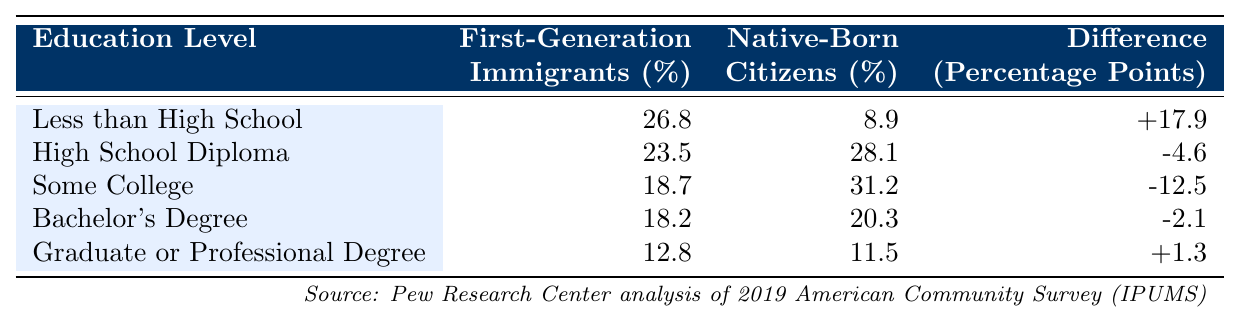What percentage of first-generation immigrants have a Bachelor's degree? From the table, the percentage of first-generation immigrants with a Bachelor's degree is 18.2%.
Answer: 18.2% What is the percentage point difference in the "Less than High School" category between first-generation immigrants and native-born citizens? The table shows that 26.8% of first-generation immigrants fall into this category compared to 8.9% of native-born citizens. The difference is +17.9 percentage points (26.8 - 8.9 = 17.9).
Answer: +17.9 Is it true that a higher percentage of native-born citizens have a Graduate or Professional Degree compared to first-generation immigrants? The table indicates that 12.8% of first-generation immigrants have a Graduate or Professional Degree, while 11.5% of native-born citizens have this degree. Therefore, it is false that a higher percentage of native-born citizens have such a degree.
Answer: No What is the average percentage of first-generation immigrants with some college or lower education levels? Looking at the relevant categories: "Less than High School" (26.8%), "High School Diploma" (23.5%), and "Some College" (18.7%), we add those percentages: 26.8 + 23.5 + 18.7 = 69.0%. There are 3 categories, so the average is 69.0 / 3 = 23.0%.
Answer: 23.0% How many percentage points more likely are first-generation immigrants to have "Less than High School" education than native-born citizens? First-generation immigrants have 26.8% in this category while native-born citizens have 8.9%. The difference is calculated as 26.8 - 8.9 = 17.9 percentage points, indicating that first-generation immigrants are more likely by this amount.
Answer: 17.9 Which education level shows the largest negative difference in percentage points between first-generation immigrants and native-born citizens? Checking the "Difference" column, "Some College" has the largest negative difference at -12.5 percentage points when comparing first-generation immigrants (18.7%) with native-born citizens (31.2%).
Answer: Some College Does a higher percentage of first-generation immigrants hold at least a Bachelor's degree compared to those with a Graduate or Professional Degree? The table shows that 18.2% of first-generation immigrants have a Bachelor's degree, while 12.8% have a Graduate or Professional Degree. Hence, it is true that a higher percentage hold at least a Bachelor's degree.
Answer: Yes What is the total percentage of native-born citizens that have either a Bachelor's Degree or a Graduate or Professional Degree? From the table, native-born citizens have 20.3% with Bachelor’s Degree and 11.5% with Graduate or Professional Degree. Adding those gives 20.3 + 11.5 = 31.8%.
Answer: 31.8% 